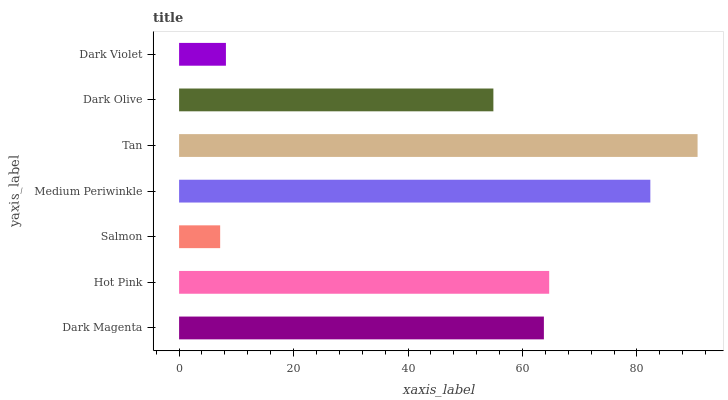Is Salmon the minimum?
Answer yes or no. Yes. Is Tan the maximum?
Answer yes or no. Yes. Is Hot Pink the minimum?
Answer yes or no. No. Is Hot Pink the maximum?
Answer yes or no. No. Is Hot Pink greater than Dark Magenta?
Answer yes or no. Yes. Is Dark Magenta less than Hot Pink?
Answer yes or no. Yes. Is Dark Magenta greater than Hot Pink?
Answer yes or no. No. Is Hot Pink less than Dark Magenta?
Answer yes or no. No. Is Dark Magenta the high median?
Answer yes or no. Yes. Is Dark Magenta the low median?
Answer yes or no. Yes. Is Tan the high median?
Answer yes or no. No. Is Hot Pink the low median?
Answer yes or no. No. 